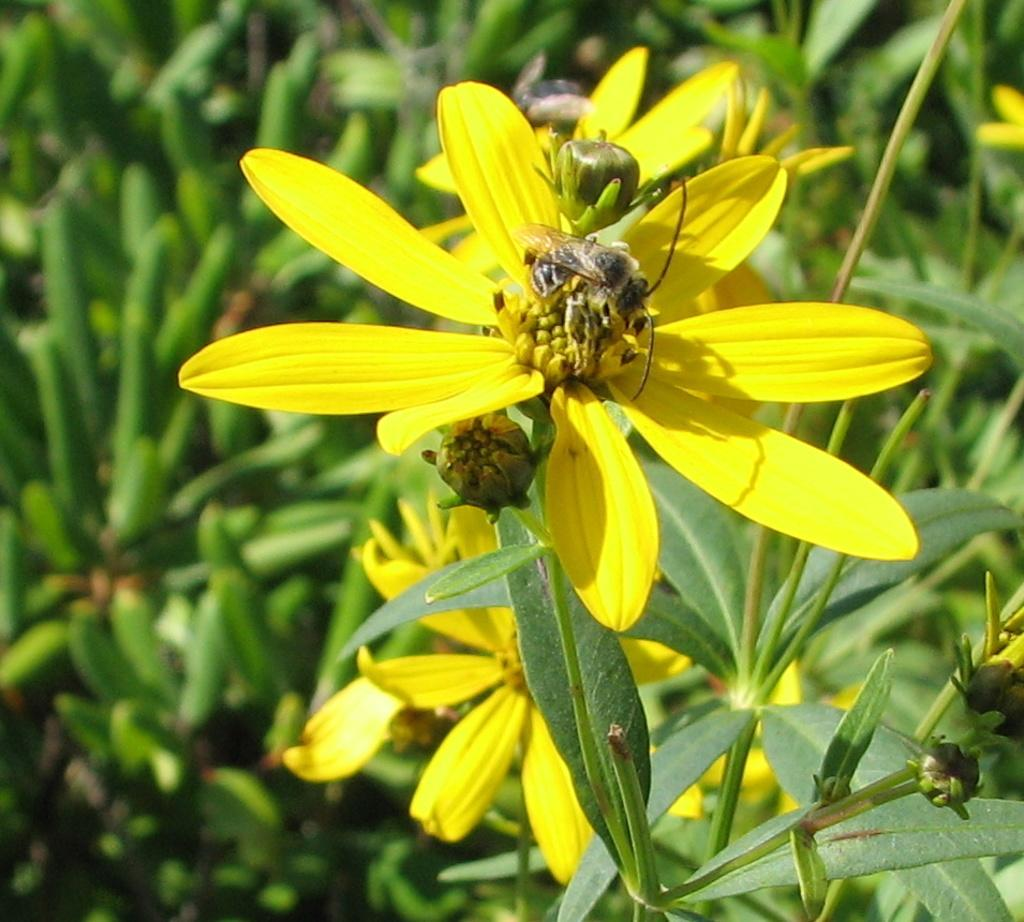What color are the flowers in the image? The flowers in the image are yellow. What can be seen in the background of the image? The background of the image includes green leaves. What type of yarn is being used to create the square in the image? There is no yarn or square present in the image; it features yellow flowers and green leaves in the background. 